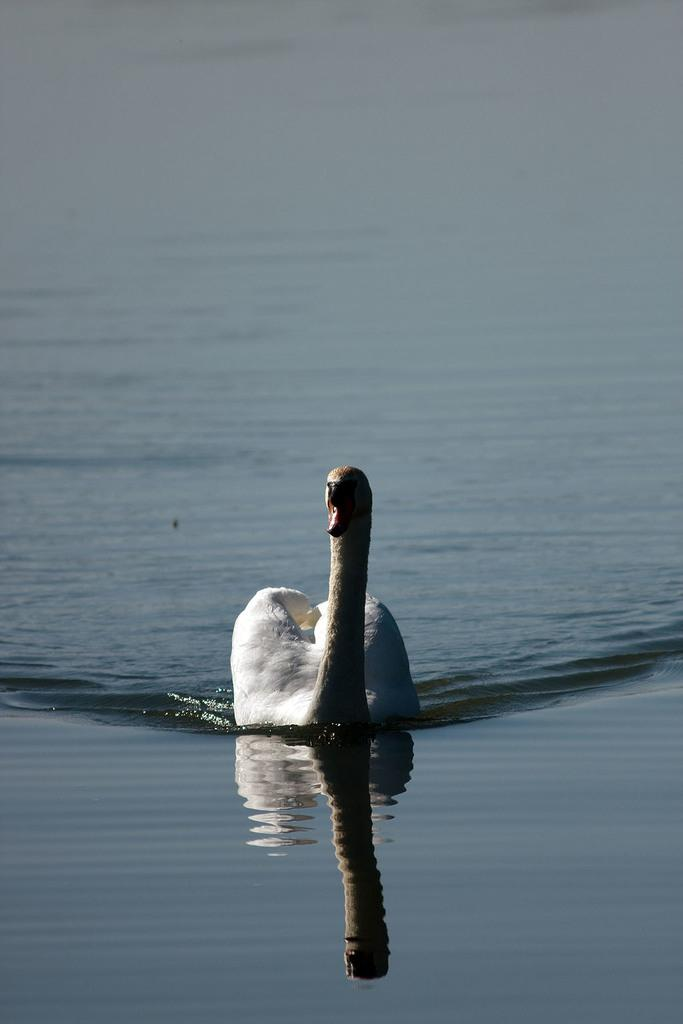What type of animal is in the image? There is a white swan in the image. What is the swan doing in the image? The swan is swimming in the river. What type of engine is powering the swan in the image? There is no engine present in the image; the swan is swimming naturally. How many cubs are visible with the swan in the image? There are no cubs present in the image; it features a single white swan. 